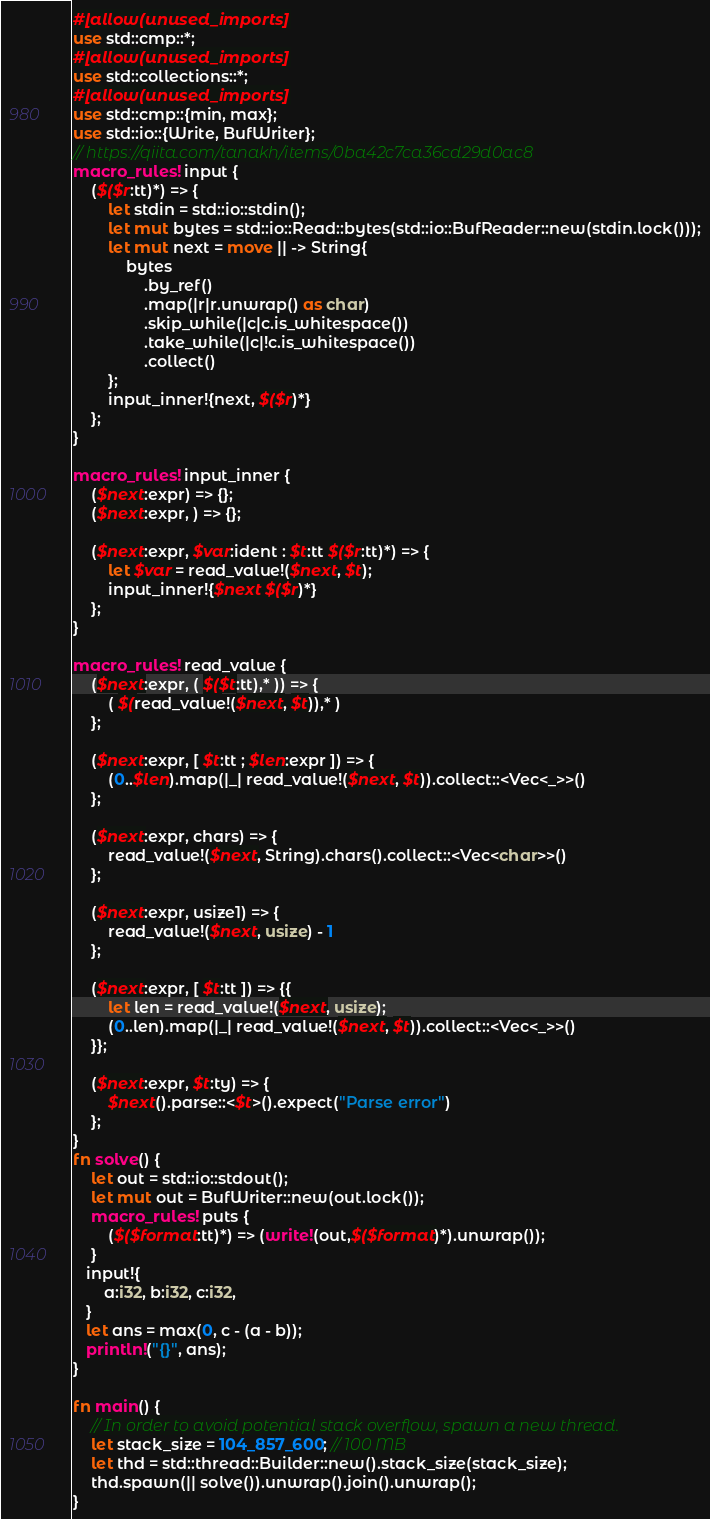Convert code to text. <code><loc_0><loc_0><loc_500><loc_500><_Rust_>#[allow(unused_imports)]
use std::cmp::*;
#[allow(unused_imports)]
use std::collections::*;
#[allow(unused_imports)]
use std::cmp::{min, max};
use std::io::{Write, BufWriter};
// https://qiita.com/tanakh/items/0ba42c7ca36cd29d0ac8
macro_rules! input {
    ($($r:tt)*) => {
        let stdin = std::io::stdin();
        let mut bytes = std::io::Read::bytes(std::io::BufReader::new(stdin.lock()));
        let mut next = move || -> String{
            bytes
                .by_ref()
                .map(|r|r.unwrap() as char)
                .skip_while(|c|c.is_whitespace())
                .take_while(|c|!c.is_whitespace())
                .collect()
        };
        input_inner!{next, $($r)*}
    };
}

macro_rules! input_inner {
    ($next:expr) => {};
    ($next:expr, ) => {};

    ($next:expr, $var:ident : $t:tt $($r:tt)*) => {
        let $var = read_value!($next, $t);
        input_inner!{$next $($r)*}
    };
}

macro_rules! read_value {
    ($next:expr, ( $($t:tt),* )) => {
        ( $(read_value!($next, $t)),* )
    };

    ($next:expr, [ $t:tt ; $len:expr ]) => {
        (0..$len).map(|_| read_value!($next, $t)).collect::<Vec<_>>()
    };

    ($next:expr, chars) => {
        read_value!($next, String).chars().collect::<Vec<char>>()
    };

    ($next:expr, usize1) => {
        read_value!($next, usize) - 1
    };

    ($next:expr, [ $t:tt ]) => {{
        let len = read_value!($next, usize);
        (0..len).map(|_| read_value!($next, $t)).collect::<Vec<_>>()
    }};

    ($next:expr, $t:ty) => {
        $next().parse::<$t>().expect("Parse error")
    };
}
fn solve() {
    let out = std::io::stdout();
    let mut out = BufWriter::new(out.lock());
    macro_rules! puts {
        ($($format:tt)*) => (write!(out,$($format)*).unwrap());
    }
   input!{
       a:i32, b:i32, c:i32,
   } 
   let ans = max(0, c - (a - b));
   println!("{}", ans);
}

fn main() {
    // In order to avoid potential stack overflow, spawn a new thread.
    let stack_size = 104_857_600; // 100 MB
    let thd = std::thread::Builder::new().stack_size(stack_size);
    thd.spawn(|| solve()).unwrap().join().unwrap();
}</code> 